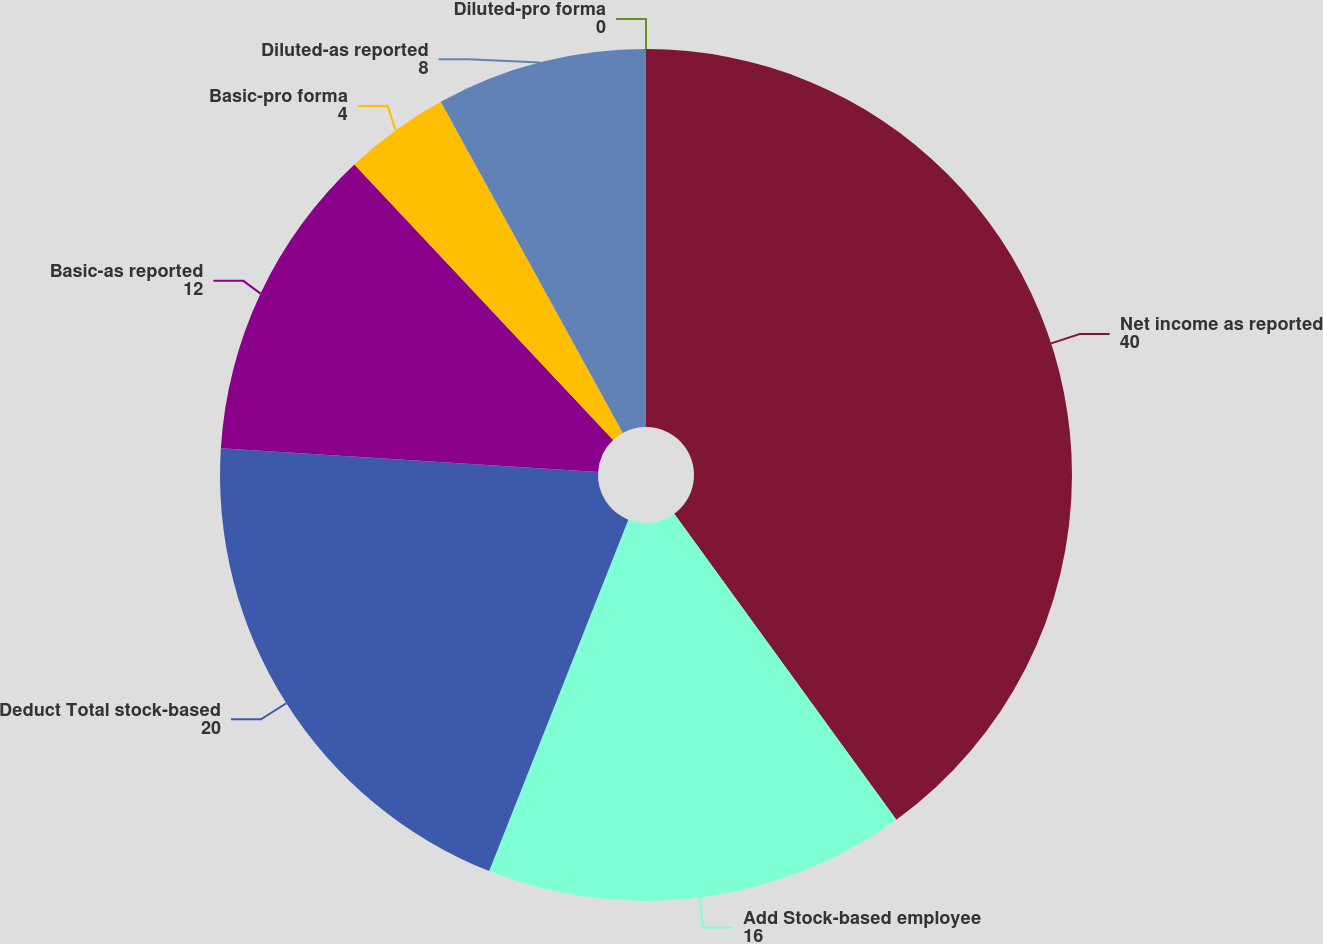Convert chart to OTSL. <chart><loc_0><loc_0><loc_500><loc_500><pie_chart><fcel>Net income as reported<fcel>Add Stock-based employee<fcel>Deduct Total stock-based<fcel>Basic-as reported<fcel>Basic-pro forma<fcel>Diluted-as reported<fcel>Diluted-pro forma<nl><fcel>40.0%<fcel>16.0%<fcel>20.0%<fcel>12.0%<fcel>4.0%<fcel>8.0%<fcel>0.0%<nl></chart> 